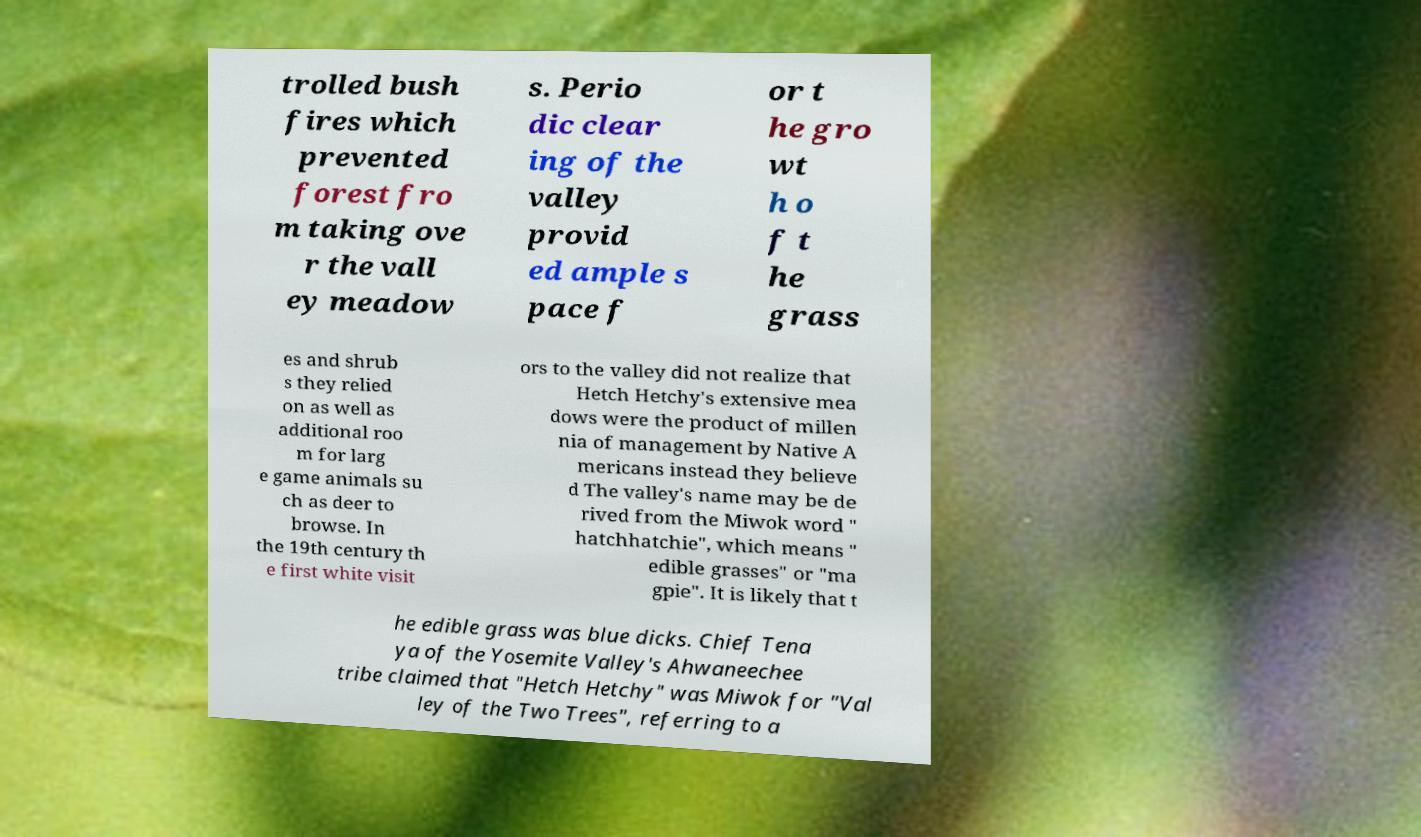I need the written content from this picture converted into text. Can you do that? trolled bush fires which prevented forest fro m taking ove r the vall ey meadow s. Perio dic clear ing of the valley provid ed ample s pace f or t he gro wt h o f t he grass es and shrub s they relied on as well as additional roo m for larg e game animals su ch as deer to browse. In the 19th century th e first white visit ors to the valley did not realize that Hetch Hetchy's extensive mea dows were the product of millen nia of management by Native A mericans instead they believe d The valley's name may be de rived from the Miwok word " hatchhatchie", which means " edible grasses" or "ma gpie". It is likely that t he edible grass was blue dicks. Chief Tena ya of the Yosemite Valley's Ahwaneechee tribe claimed that "Hetch Hetchy" was Miwok for "Val ley of the Two Trees", referring to a 